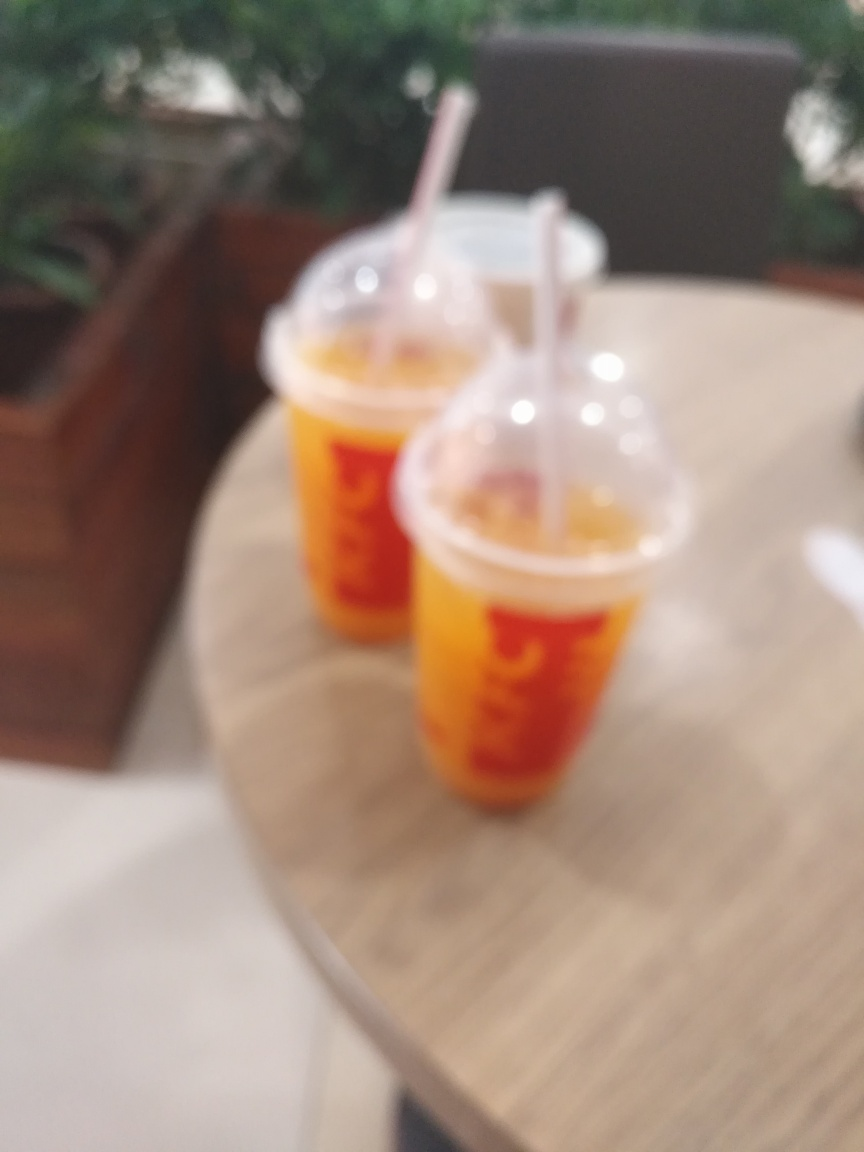What could be the reason this image is out of focus? The image could be out of focus due to several reasons such as camera shake, incorrect camera settings for the lighting conditions, or an unintentional touch on the camera lens while taking the photo, causing a smudge that blurs the image. Can you determine the location where this image might have been taken? It's challenging to determine the exact location due to the lack of clear details; however, it appears to be an indoor setting. The presence of cups that typically contain beverages suggests it could be a cafe or a fast-food restaurant. 